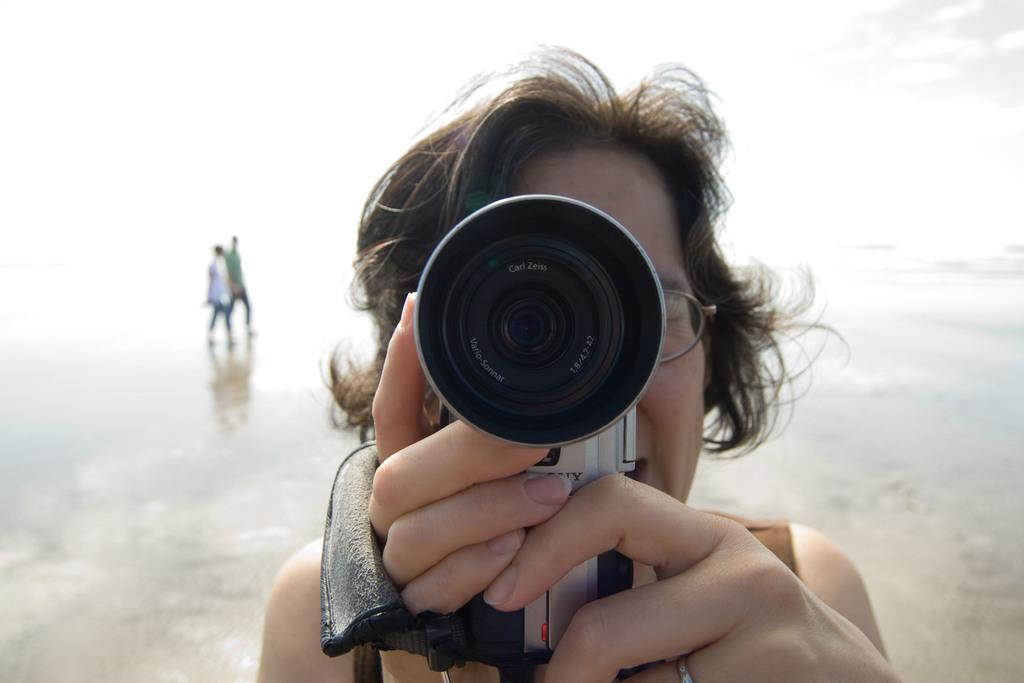What is the person in the middle of the image doing? The person in the middle of the image is holding a camera. Can you describe the position of the person holding the camera? The person holding the camera is in the middle of the image. What are the two persons at the back side of the image doing? The two persons at the back side of the image are walking. What type of food is the person holding the camera eating in the image? There is no food present in the image, and the person holding the camera is not eating. 